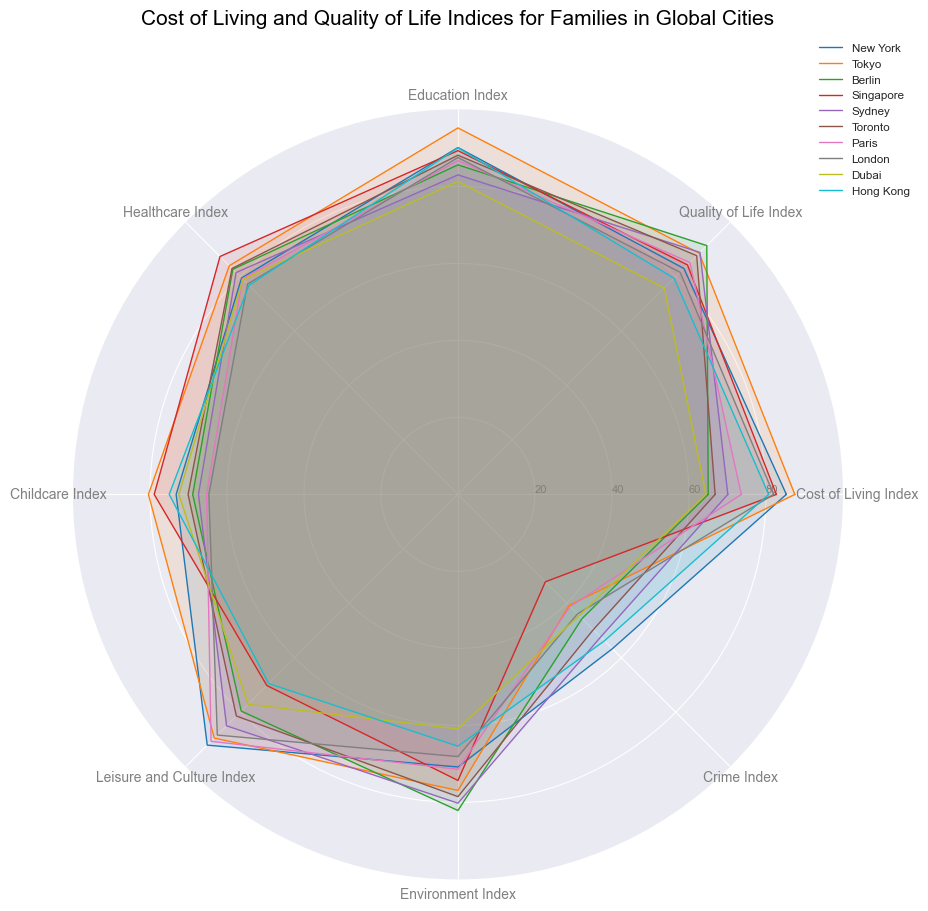Which city has the highest Cost of Living Index? To find the highest Cost of Living Index, look at the radial axis labeled "Cost of Living Index" and find the city with the widest reach on this axis. Tokyo has the highest value at 87.5.
Answer: Tokyo Which city seems to have the best quality of education based on the Education Index? To identify the city with the highest Education Index, look for the radial axis labeled "Education Index" and see which city's plot line extends the furthest. Tokyo has the highest value at 95.2.
Answer: Tokyo Is the Quality of Life Index higher in Berlin or New York? Compare the lengths of the radial lines for the Quality of Life Index for both Berlin and New York. Berlin's Quality of Life Index reaches further out at 91.4 compared to New York's 83.0.
Answer: Berlin Which city has the lowest Crime Index? The Crime Index is plotted in reverse (lower is better), so find the city with the smallest reach on this axis. Singapore has the lowest Crime Index at 32.1.
Answer: Singapore What is the average Education Index for Berlin, Sydney, and Toronto? Add the Education Indices for Berlin (85.6), Sydney (83.0), and Toronto (88.1) then divide by 3. (85.6 + 83.0 + 88.1) / 3 = 85.57.
Answer: 85.57 Which city has the best Healthcare Index? Locate the radial axis labeled "Healthcare Index" and find the city with the longest reach. Singapore has the best Healthcare Index at 87.4.
Answer: Singapore Does Paris have a better Leisure and Culture Index than London? Compare the lengths of the radial lines for the Leisure and Culture Index for Paris and London. Paris extends out to 90.7, while London reaches 88.4.
Answer: Yes What is the difference between the Childcare Index of Tokyo and Dubai? Subtract Dubai's Childcare Index (72.5) from Tokyo's Childcare Index (80.4). 80.4 - 72.5 = 7.9
Answer: 7.9 Which city appears to have the best balance between Cost of Living Index and Quality of Life Index? Look for a city where both indices are both relatively high and similarly sized. Tokyo has a high Cost of Living Index (87.5) and Quality of Life Index (88.6), making it the best balanced.
Answer: Tokyo How does the Environment Index of Toronto compare to New York? Compare the lengths of the radial lines for the Environment Index of Toronto and New York. Toronto's Environment Index is 78.5, and New York's is 70.8. Toronto has a higher value.
Answer: Toronto 